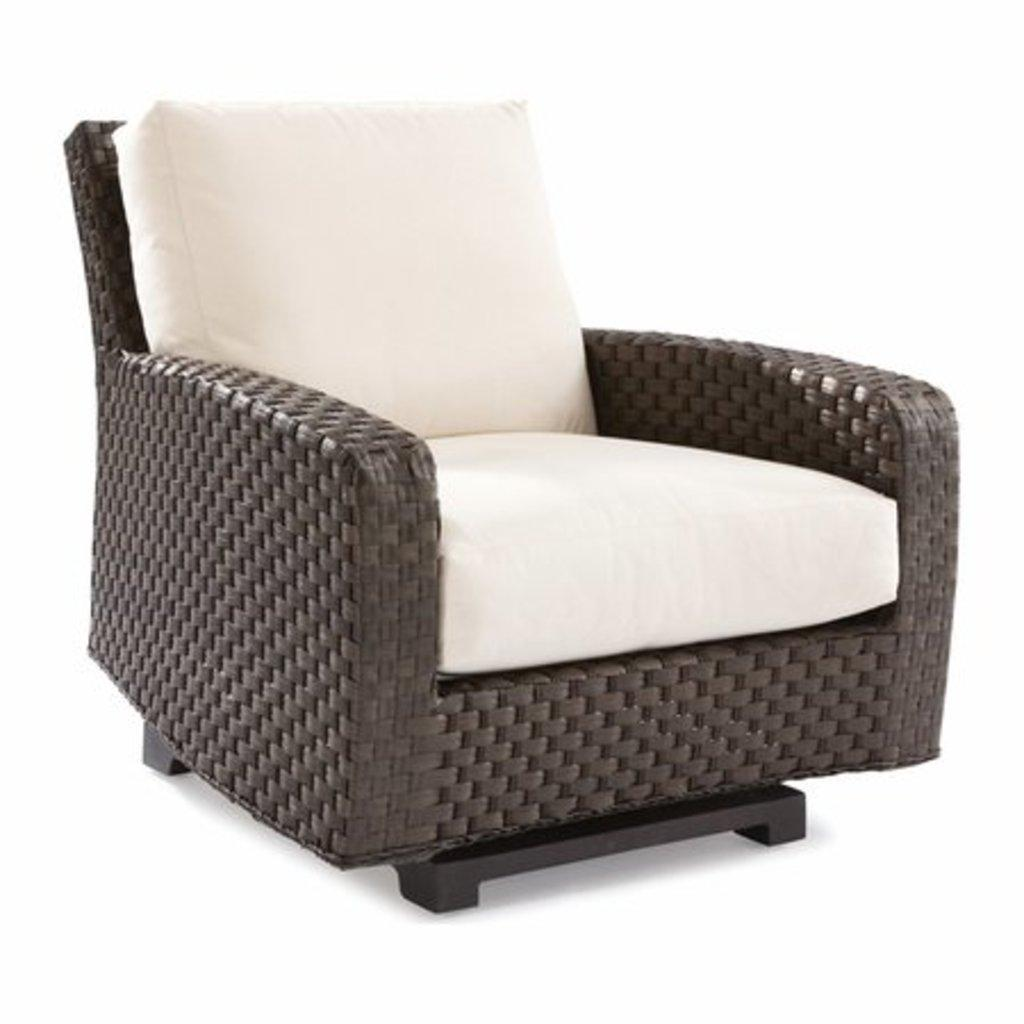What type of chair is in the image? There is a brown color chair in the image. Are there any decorative elements on the chair? Yes, there are cream colored pillows on the chair. What color is the background of the image? The background of the image is white. What type of vessel is used to serve the bears in the image? There are no bears or vessels present in the image. 